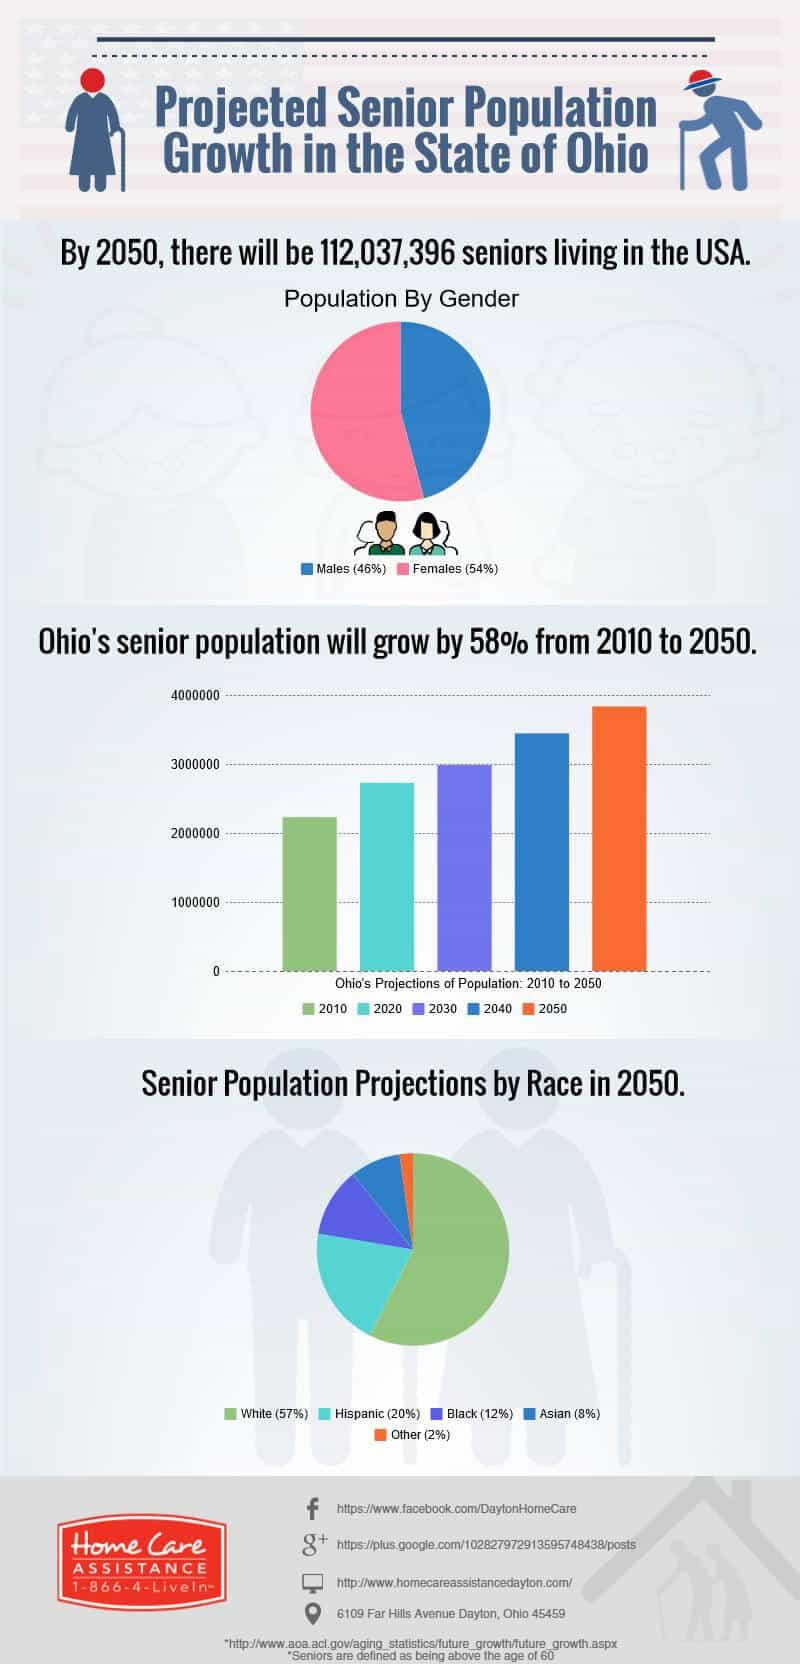Identify some key points in this picture. In 2030, the senior population in Ohio is projected to reach 3 million, according to estimates. According to projections, in 2050, the second highest percentage of senior citizens will be of Hispanic descent. According to the prediction, the second lowest percentage of senior population in 2050 will be of Asian ethnicity. It is predicted that by 2050, the population of females will be higher than that of males. 